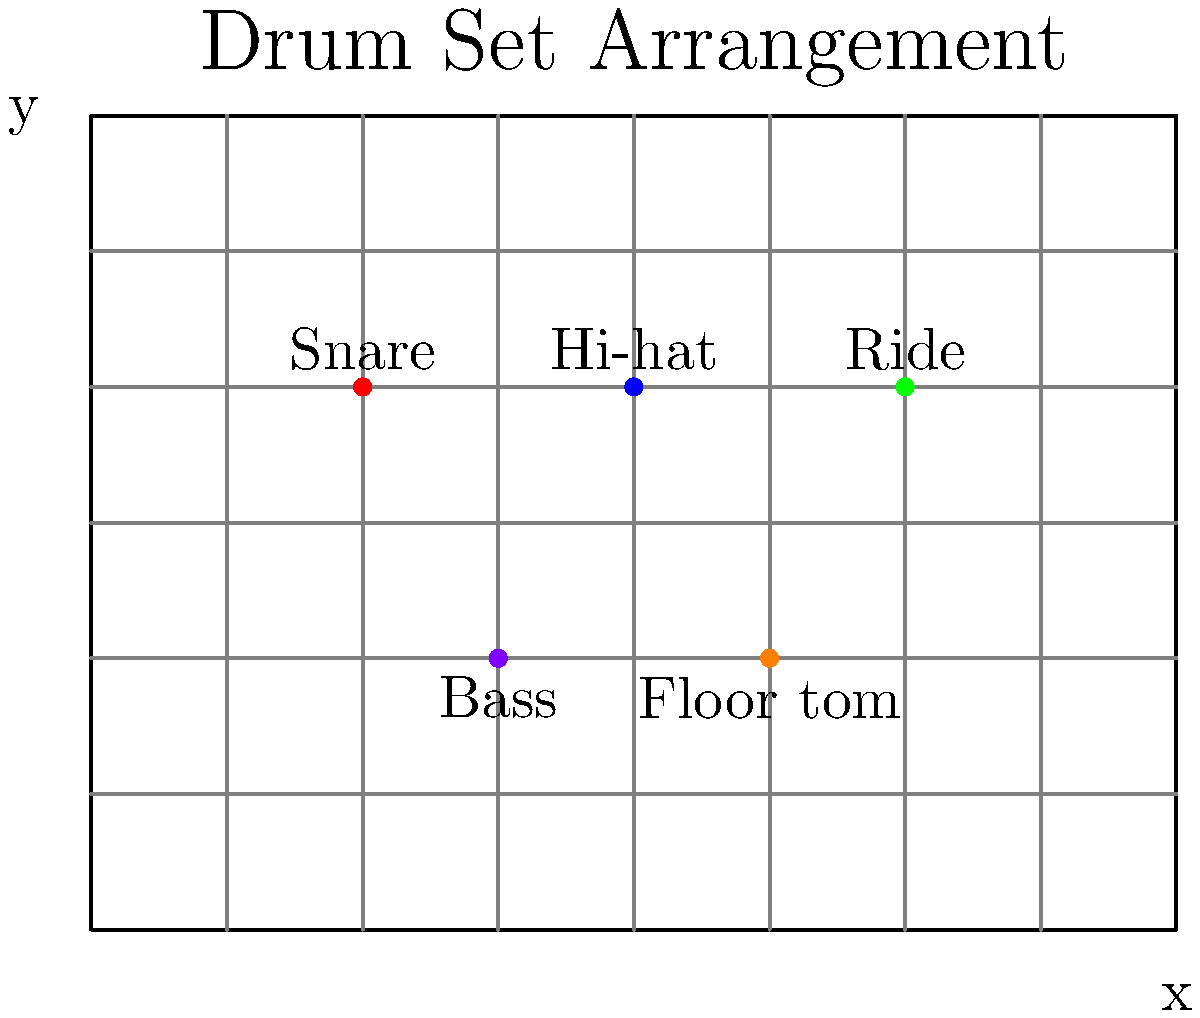As a drummer and graphic designer, you're tasked with creating a precise layout for your band's stage setup. The stage is represented by an 8x6 grid, where each unit corresponds to 1 meter. Your drum set arrangement is shown in the diagram above. If the origin (0,0) is at the bottom-left corner of the stage, what are the coordinates of the bass drum? To find the coordinates of the bass drum, we need to analyze the grid and locate the bass drum's position. Let's break it down step-by-step:

1. Observe the grid: The stage is represented by an 8x6 grid, with the origin (0,0) at the bottom-left corner.

2. Identify the bass drum: In the diagram, the bass drum is labeled and represented by a purple dot.

3. Determine the x-coordinate:
   - Count the number of units from the left edge of the stage to the bass drum.
   - The bass drum is positioned 3 units from the left edge.
   - Therefore, the x-coordinate is 3.

4. Determine the y-coordinate:
   - Count the number of units from the bottom edge of the stage to the bass drum.
   - The bass drum is positioned 2 units from the bottom edge.
   - Therefore, the y-coordinate is 2.

5. Combine the coordinates: The position of the bass drum can be expressed as the ordered pair (x, y).

Thus, the coordinates of the bass drum are (3, 2).
Answer: (3, 2) 